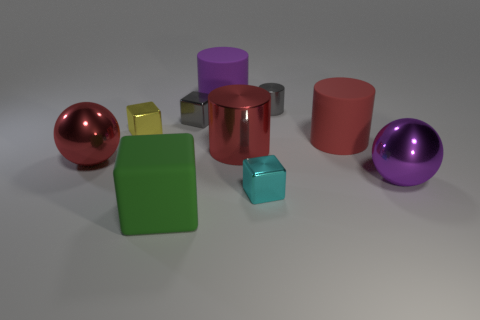Subtract all brown balls. How many red cylinders are left? 2 Subtract all small cyan shiny blocks. How many blocks are left? 3 Subtract 2 cylinders. How many cylinders are left? 2 Subtract all yellow blocks. How many blocks are left? 3 Subtract all brown cubes. Subtract all gray balls. How many cubes are left? 4 Subtract all balls. How many objects are left? 8 Add 2 big things. How many big things exist? 8 Subtract 0 blue cylinders. How many objects are left? 10 Subtract all gray things. Subtract all small shiny blocks. How many objects are left? 5 Add 7 yellow metallic cubes. How many yellow metallic cubes are left? 8 